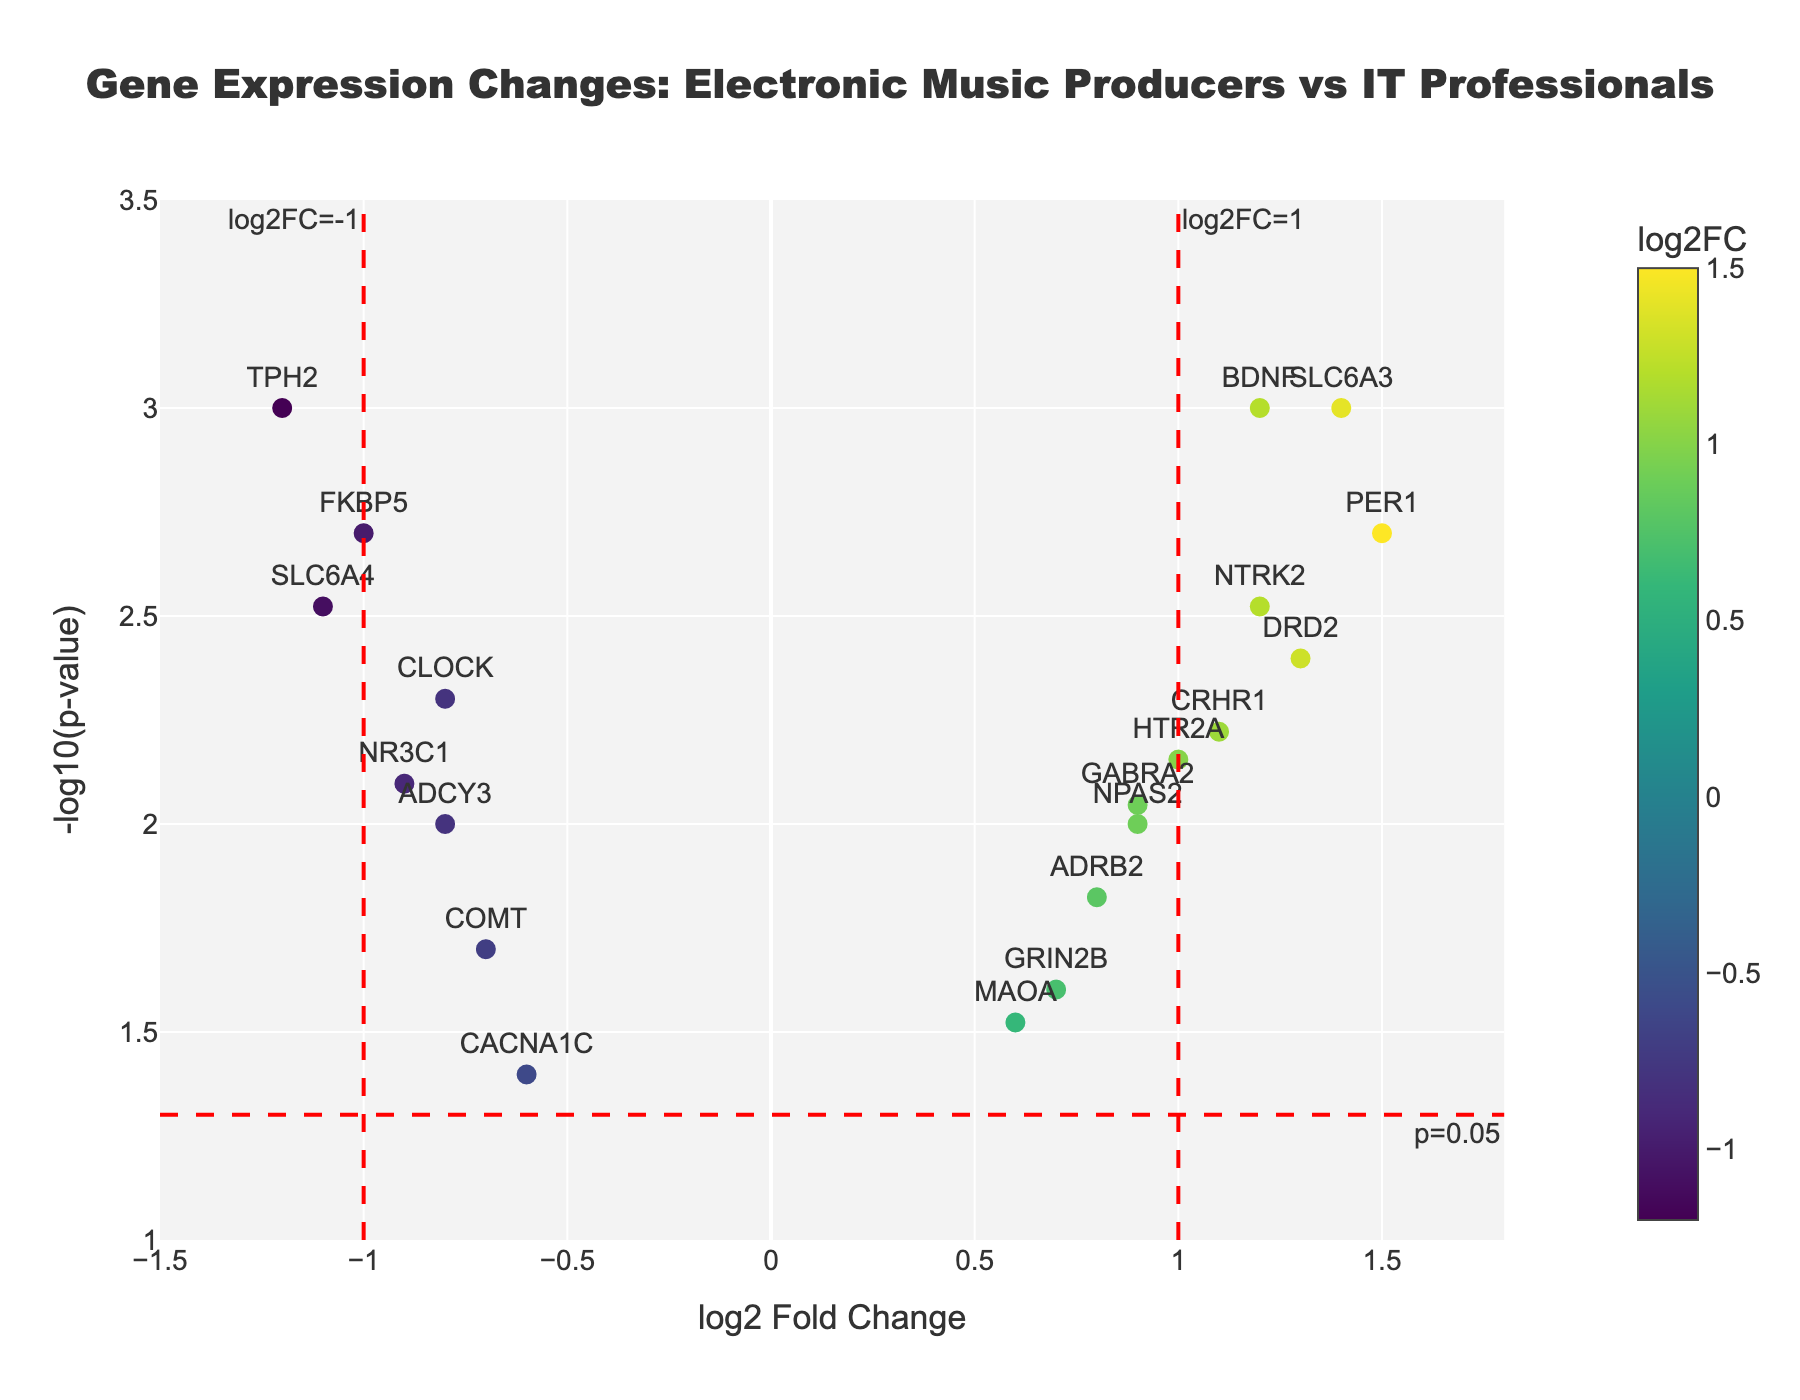what is the title of the plot? The title is located at the top of the plot. It prominently reads "Gene Expression Changes: Electronic Music Producers vs IT Professionals."
Answer: Gene Expression Changes: Electronic Music Producers vs IT Professionals what are the x-axis and y-axis labels of the plot? The x-axis label is "log2 Fold Change," and the y-axis label is "-log10(p-value)." These labels are written along their respective axes.
Answer: log2 Fold Change and -log10(p-value) How many genes have a p-value less than 0.005? To determine this, check the y-axis value where -log10(p-value) > -log10(0.005). Count the markers higher than this threshold line.
Answer: 7 Which gene has the highest log2 fold change? Look for the marker furthest to the right on the x-axis. The corresponding text label identifies the gene with the highest value.
Answer: PER1 Are there any genes with a log2 fold change around -0.8? Check along the x-axis around -0.8 and identify the corresponding markers. The text labels show the genes' names.
Answer: CLOCK and ADCY3 Which gene has the lowest p-value? The gene with the highest value on the y-axis has the lowest p-value, as -log10(p-value) is plotted on the y-axis.
Answer: BDNF How many genes have a log2 fold change greater than 1? Count the number of markers to the right of the x=1 threshold line.
Answer: 3 What color represents the highest log2 fold changes on the color scale? Check the color bar beside the scatter plot. The color corresponding to the highest values on this bar is the answer.
Answer: Yellow Which genes are marked in the region where the log2 fold change is ≤ -1 and -log10(p-value) > -log10(0.05)? Identify markers left of the x=-1 threshold that are above the y-line at -log10(p-value) = -log10(0.05). The text labels reveal the gene names.
Answer: SLC6A4 and TPH2 